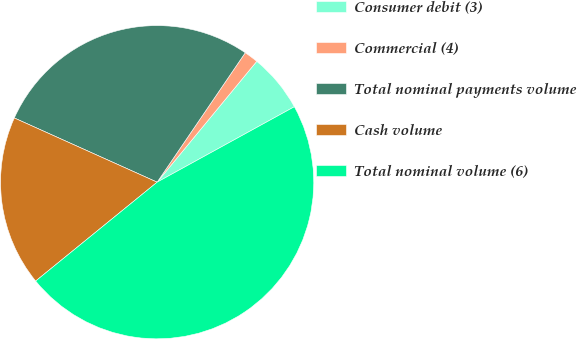Convert chart. <chart><loc_0><loc_0><loc_500><loc_500><pie_chart><fcel>Consumer debit (3)<fcel>Commercial (4)<fcel>Total nominal payments volume<fcel>Cash volume<fcel>Total nominal volume (6)<nl><fcel>6.03%<fcel>1.46%<fcel>27.79%<fcel>17.6%<fcel>47.13%<nl></chart> 